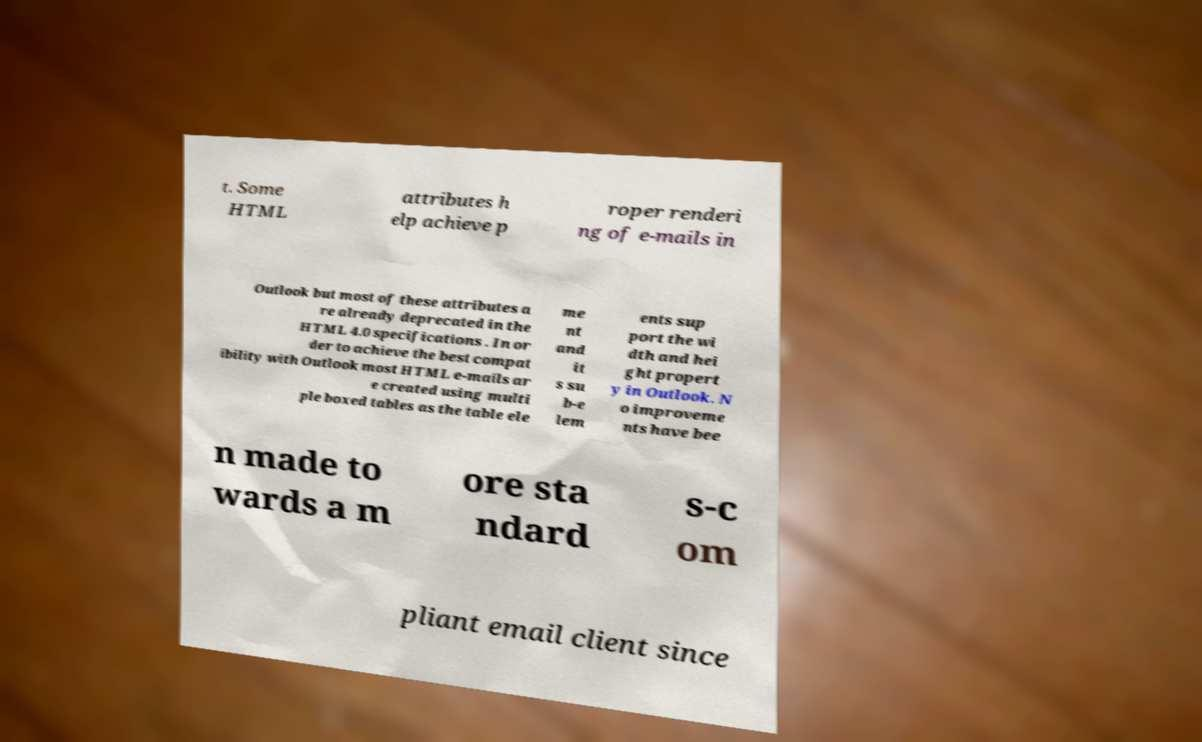Can you read and provide the text displayed in the image?This photo seems to have some interesting text. Can you extract and type it out for me? t. Some HTML attributes h elp achieve p roper renderi ng of e-mails in Outlook but most of these attributes a re already deprecated in the HTML 4.0 specifications . In or der to achieve the best compat ibility with Outlook most HTML e-mails ar e created using multi ple boxed tables as the table ele me nt and it s su b-e lem ents sup port the wi dth and hei ght propert y in Outlook. N o improveme nts have bee n made to wards a m ore sta ndard s-c om pliant email client since 